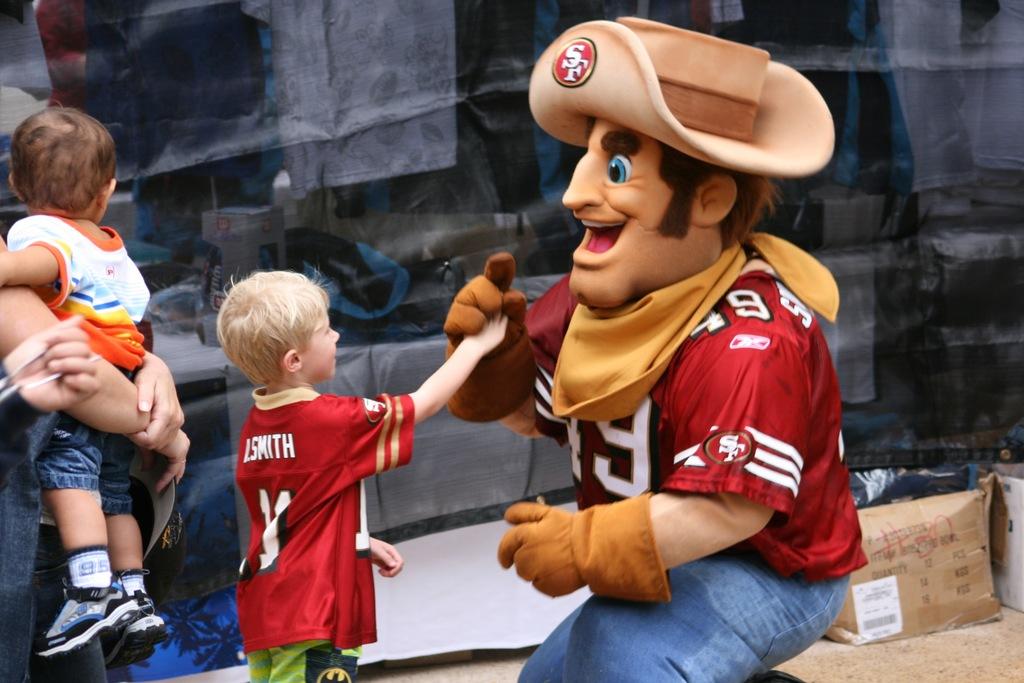Who's jersey is the kid wearing?
Keep it short and to the point. Smith. 